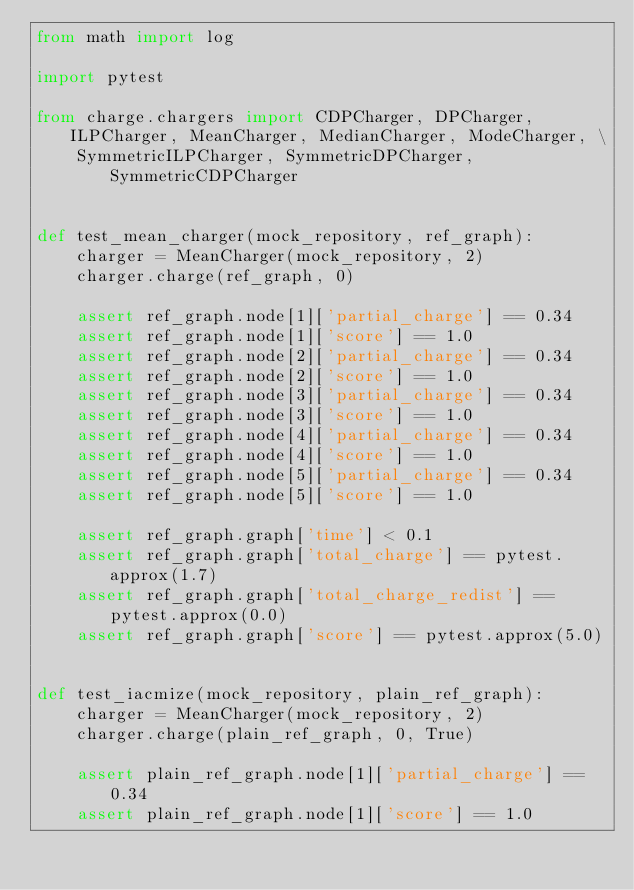<code> <loc_0><loc_0><loc_500><loc_500><_Python_>from math import log

import pytest

from charge.chargers import CDPCharger, DPCharger, ILPCharger, MeanCharger, MedianCharger, ModeCharger, \
    SymmetricILPCharger, SymmetricDPCharger, SymmetricCDPCharger


def test_mean_charger(mock_repository, ref_graph):
    charger = MeanCharger(mock_repository, 2)
    charger.charge(ref_graph, 0)

    assert ref_graph.node[1]['partial_charge'] == 0.34
    assert ref_graph.node[1]['score'] == 1.0
    assert ref_graph.node[2]['partial_charge'] == 0.34
    assert ref_graph.node[2]['score'] == 1.0
    assert ref_graph.node[3]['partial_charge'] == 0.34
    assert ref_graph.node[3]['score'] == 1.0
    assert ref_graph.node[4]['partial_charge'] == 0.34
    assert ref_graph.node[4]['score'] == 1.0
    assert ref_graph.node[5]['partial_charge'] == 0.34
    assert ref_graph.node[5]['score'] == 1.0

    assert ref_graph.graph['time'] < 0.1
    assert ref_graph.graph['total_charge'] == pytest.approx(1.7)
    assert ref_graph.graph['total_charge_redist'] == pytest.approx(0.0)
    assert ref_graph.graph['score'] == pytest.approx(5.0)


def test_iacmize(mock_repository, plain_ref_graph):
    charger = MeanCharger(mock_repository, 2)
    charger.charge(plain_ref_graph, 0, True)

    assert plain_ref_graph.node[1]['partial_charge'] == 0.34
    assert plain_ref_graph.node[1]['score'] == 1.0</code> 